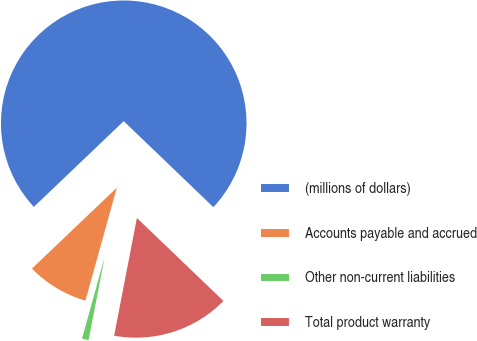Convert chart to OTSL. <chart><loc_0><loc_0><loc_500><loc_500><pie_chart><fcel>(millions of dollars)<fcel>Accounts payable and accrued<fcel>Other non-current liabilities<fcel>Total product warranty<nl><fcel>74.29%<fcel>8.57%<fcel>1.27%<fcel>15.87%<nl></chart> 